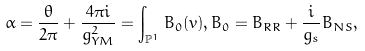<formula> <loc_0><loc_0><loc_500><loc_500>\alpha = \frac { \theta } { 2 \pi } + \frac { 4 \pi i } { g ^ { 2 } _ { Y M } } = \int _ { \mathbb { P } ^ { 1 } } B _ { 0 } ( v ) , B _ { 0 } = B _ { R R } + \frac { i } { g _ { s } } B _ { N S } ,</formula> 